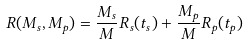<formula> <loc_0><loc_0><loc_500><loc_500>R ( M _ { s } , M _ { p } ) = \frac { M _ { s } } { M } R _ { s } ( t _ { s } ) + \frac { M _ { p } } { M } R _ { p } ( t _ { p } )</formula> 